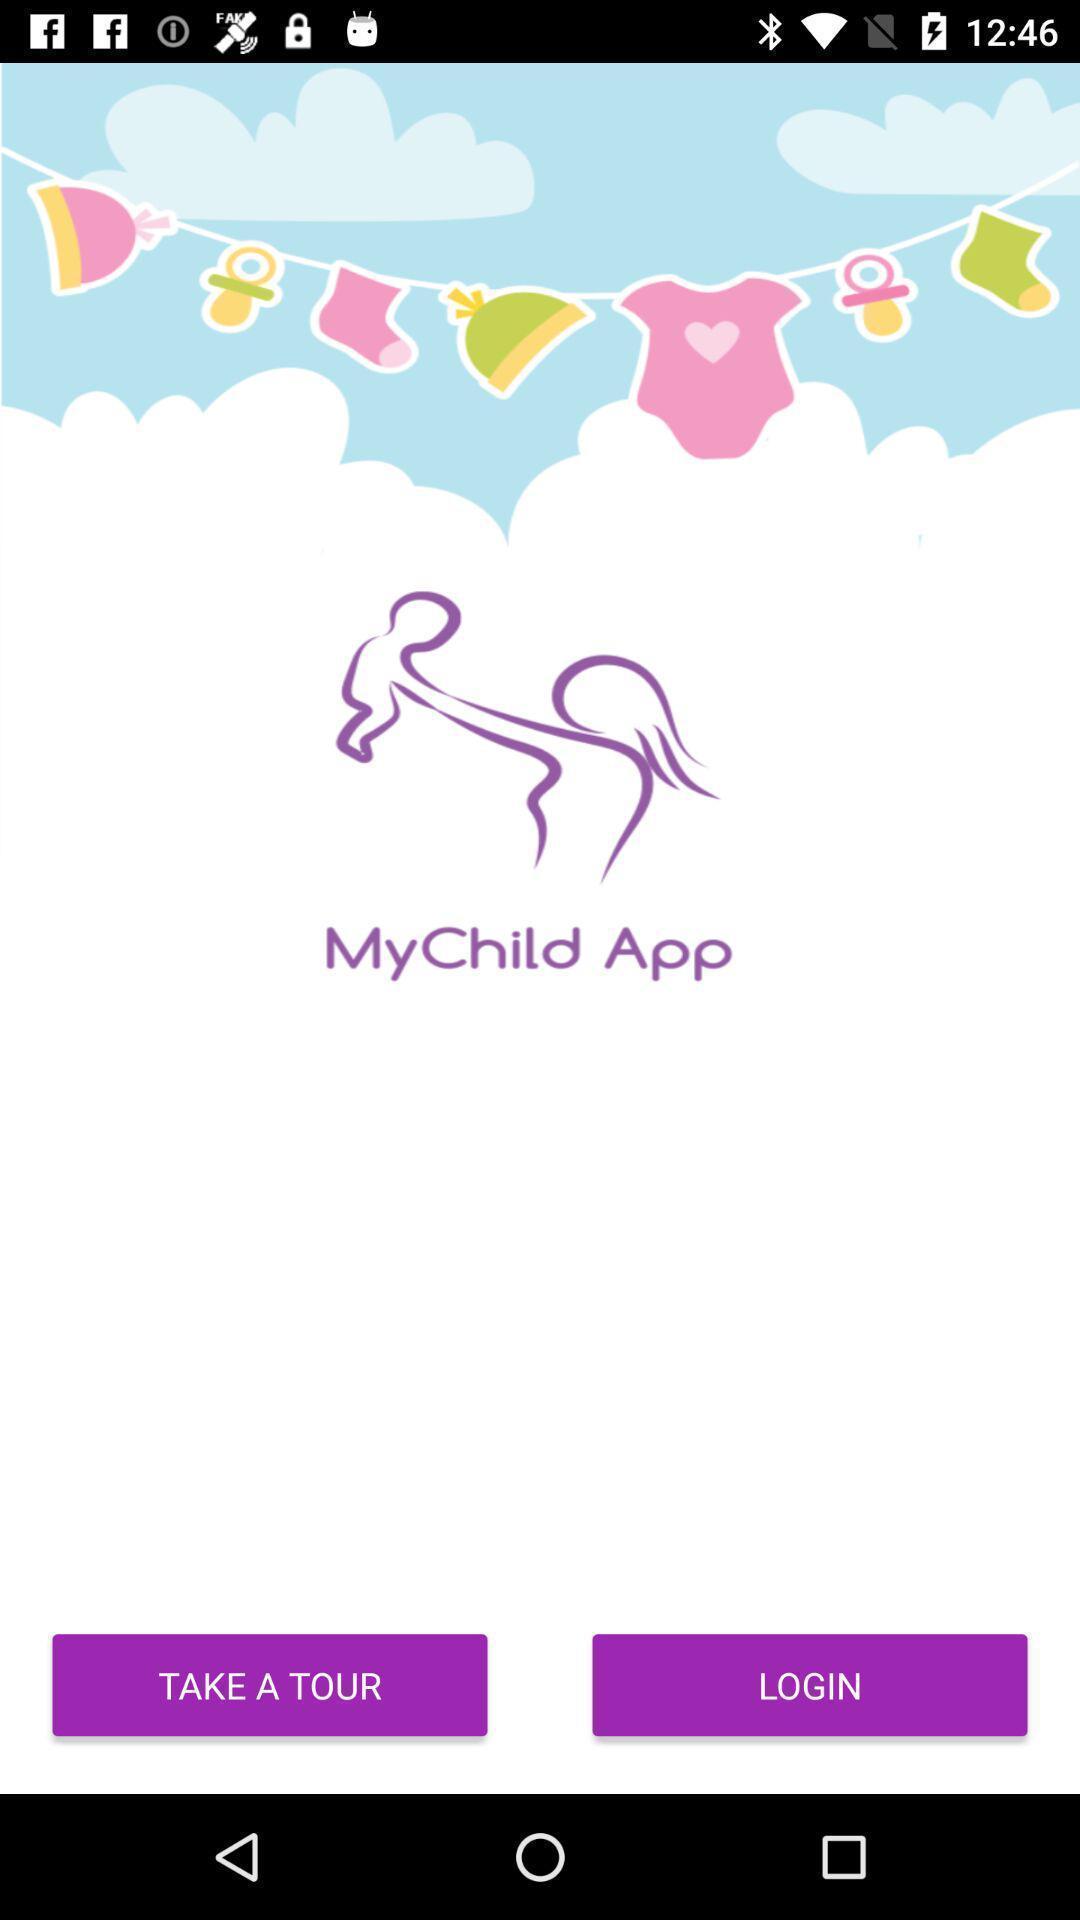Tell me what you see in this picture. Welcome page. 